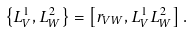<formula> <loc_0><loc_0><loc_500><loc_500>\left \{ L _ { V } ^ { 1 } , L _ { W } ^ { 2 } \right \} = \left [ r _ { V W } , L _ { V } ^ { 1 } L _ { W } ^ { 2 } \right ] .</formula> 